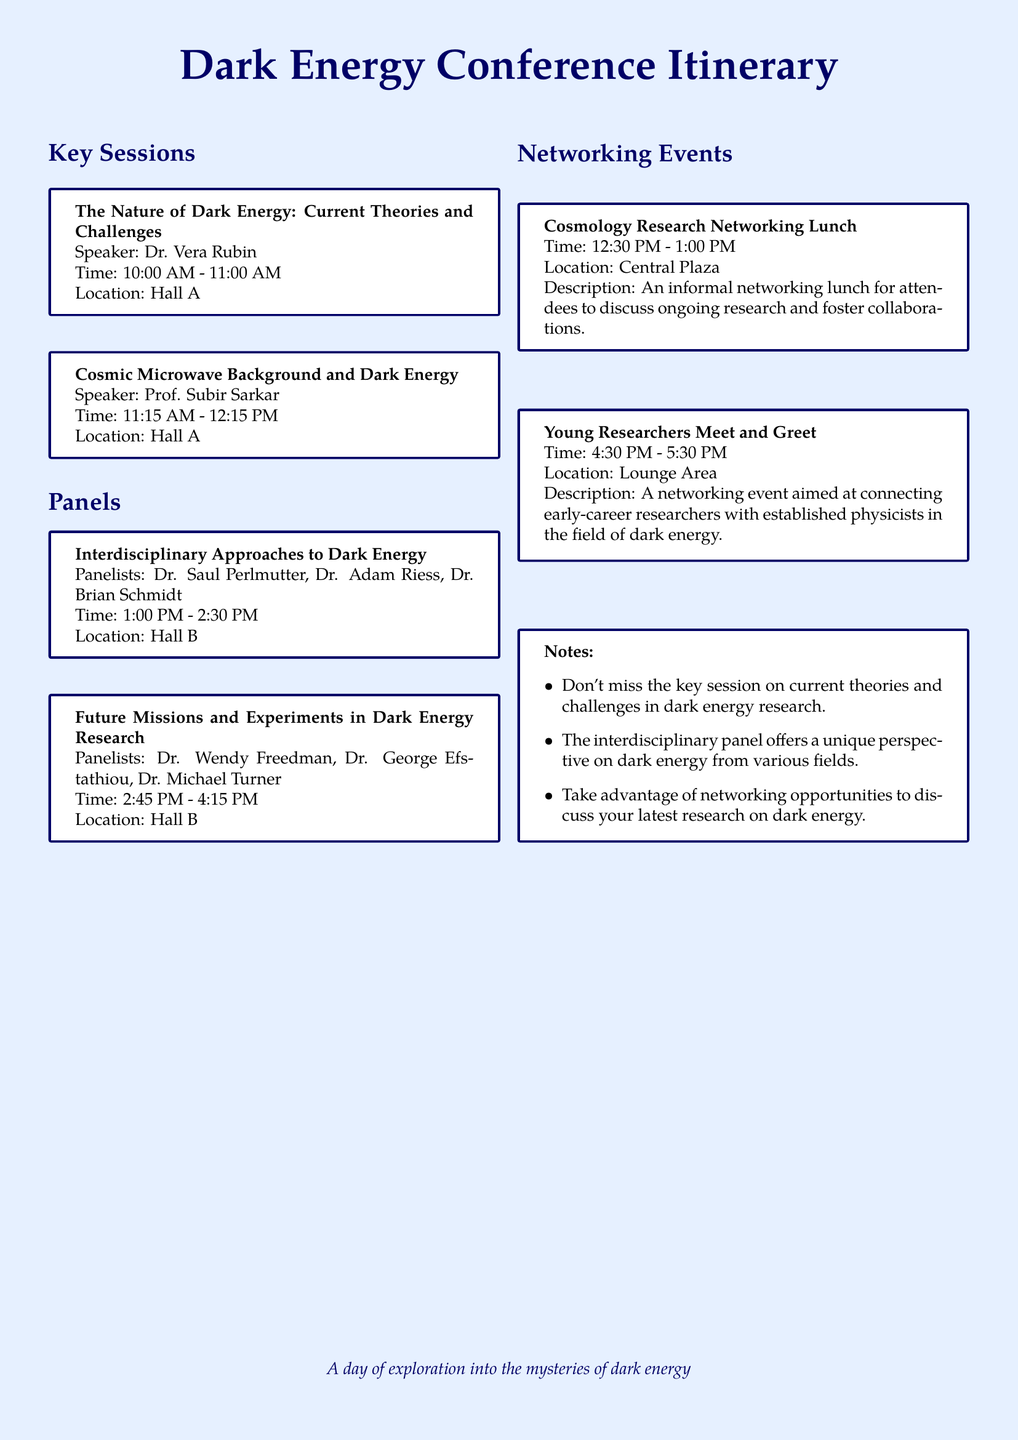What time is the session on the nature of dark energy? The session begins at 10:00 AM and ends at 11:00 AM, according to the itinerary.
Answer: 10:00 AM - 11:00 AM Who is the speaker for the Cosmic Microwave Background session? The speaker listed for this session is Prof. Subir Sarkar.
Answer: Prof. Subir Sarkar What is the location of the networking lunch? The networking lunch is held at Central Plaza as stated in the document.
Answer: Central Plaza How long is the interdisciplinary panel on dark energy? The panel on interdisciplinary approaches lasts for 1.5 hours, from 1:00 PM to 2:30 PM.
Answer: 1.5 hours Which event is aimed at early-career researchers? The Young Researchers Meet and Greet is specifically designed for early-career researchers to connect.
Answer: Young Researchers Meet and Greet What is the main focus of the key session led by Dr. Vera Rubin? The focus of the session is on current theories and challenges related to dark energy.
Answer: Current theories and challenges How many panelists are there in the Future Missions panel? There are three panelists in the Future Missions and Experiments in Dark Energy Research panel.
Answer: Three What time does the Young Researchers Meet and Greet start? The event starts at 4:30 PM as indicated in the itinerary.
Answer: 4:30 PM 